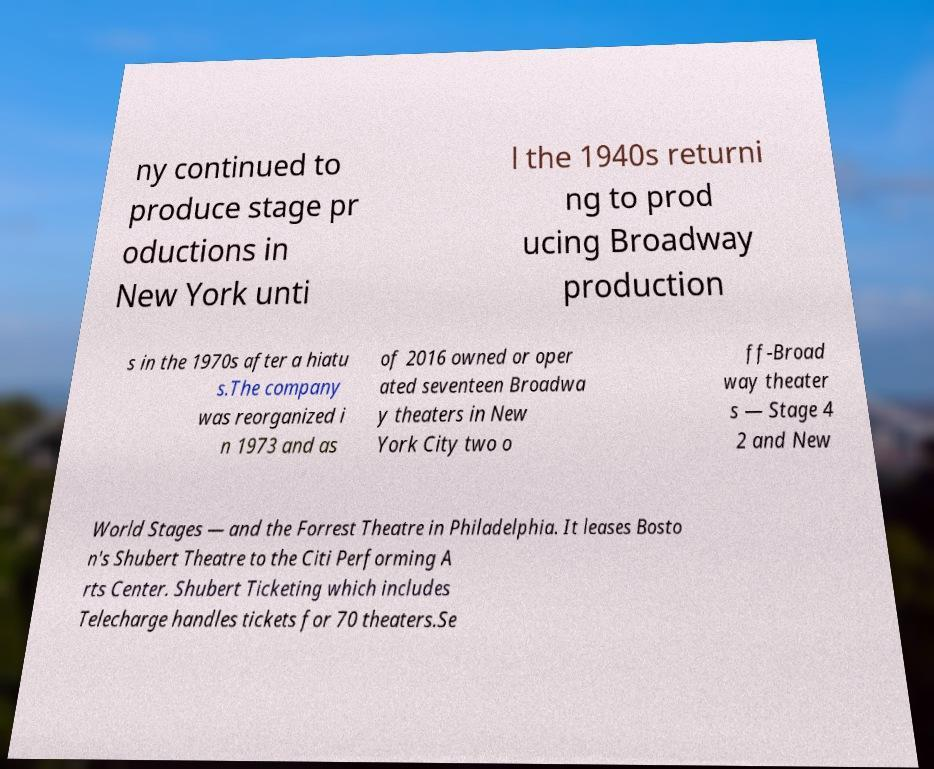For documentation purposes, I need the text within this image transcribed. Could you provide that? ny continued to produce stage pr oductions in New York unti l the 1940s returni ng to prod ucing Broadway production s in the 1970s after a hiatu s.The company was reorganized i n 1973 and as of 2016 owned or oper ated seventeen Broadwa y theaters in New York City two o ff-Broad way theater s — Stage 4 2 and New World Stages — and the Forrest Theatre in Philadelphia. It leases Bosto n's Shubert Theatre to the Citi Performing A rts Center. Shubert Ticketing which includes Telecharge handles tickets for 70 theaters.Se 